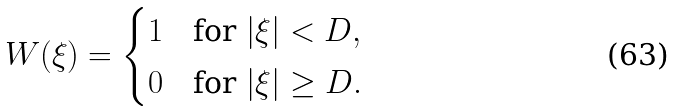<formula> <loc_0><loc_0><loc_500><loc_500>W ( \xi ) = \begin{cases} 1 & \text {for} \ | \xi | < D , \\ 0 & \text {for} \ | \xi | \geq D . \end{cases}</formula> 